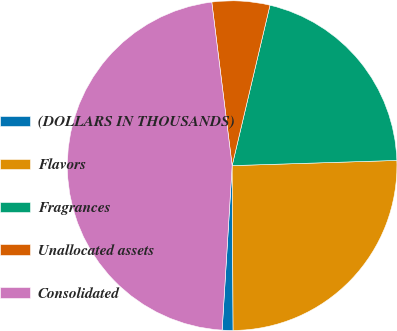Convert chart. <chart><loc_0><loc_0><loc_500><loc_500><pie_chart><fcel>(DOLLARS IN THOUSANDS)<fcel>Flavors<fcel>Fragrances<fcel>Unallocated assets<fcel>Consolidated<nl><fcel>1.06%<fcel>25.41%<fcel>20.81%<fcel>5.66%<fcel>47.06%<nl></chart> 